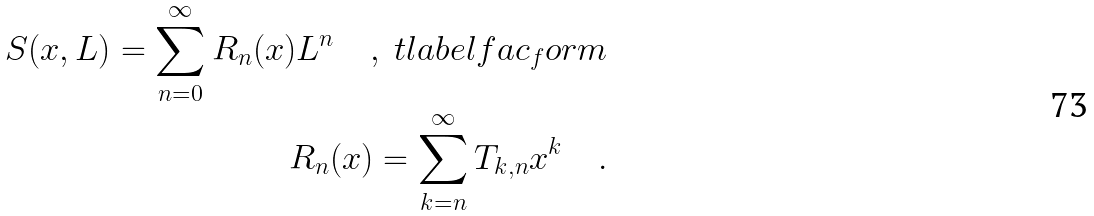Convert formula to latex. <formula><loc_0><loc_0><loc_500><loc_500>S ( x , L ) = \sum _ { n = 0 } ^ { \infty } R _ { n } ( x ) L ^ { n } \quad , \ t l a b e l { f a c _ { f } o r m } \\ R _ { n } ( x ) = \sum _ { k = n } ^ { \infty } T _ { k , n } x ^ { k } \quad .</formula> 